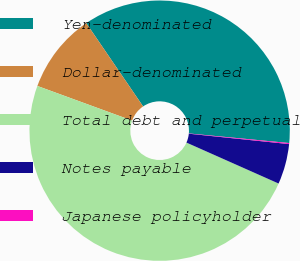<chart> <loc_0><loc_0><loc_500><loc_500><pie_chart><fcel>Yen-denominated<fcel>Dollar-denominated<fcel>Total debt and perpetual<fcel>Notes payable<fcel>Japanese policyholder<nl><fcel>36.04%<fcel>9.89%<fcel>48.92%<fcel>5.01%<fcel>0.13%<nl></chart> 